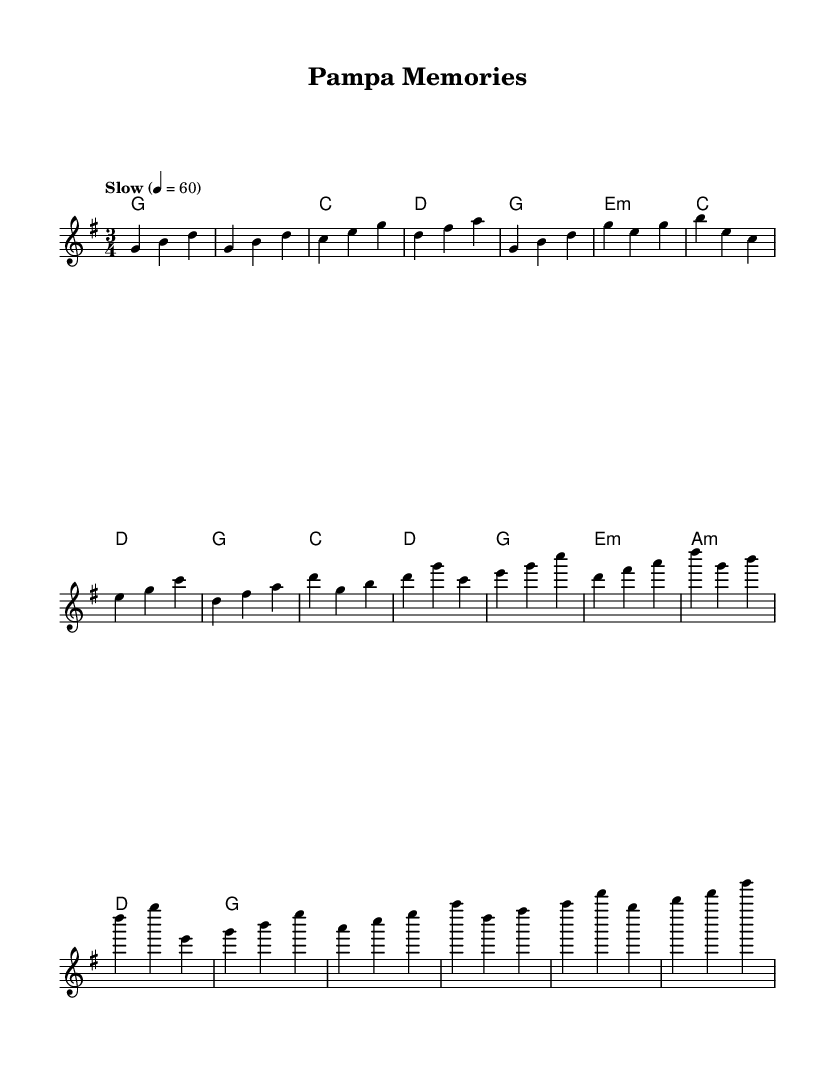What is the key signature of this music? The key signature is G major, which has one sharp (F#). This can be confirmed by examining the notes and identifying that the piece centers around G as the tonic.
Answer: G major What is the time signature of this music? The time signature is 3/4, indicated at the beginning of the score. This means there are three beats per measure, and each quarter note gets one beat.
Answer: 3/4 What is the tempo marking for this piece? The tempo marking is "Slow" set to 4 = 60, which means to play at 60 beats per minute. This is noted above the staff in the tempo indication.
Answer: Slow What chord follows the introduction? The chord following the introduction is E minor (e:m). This can be deduced by looking at the chord progression after the intro section in the harmony part.
Answer: E minor What is the structure of the song? The structure consists of an Intro, Verse 1, Chorus, and Bridge. This can be observed from the arrangement of the sections in the melody and harmony parts.
Answer: Intro, Verse 1, Chorus, Bridge What emotion does this traditional ballad evoke? The traditional country ballad evokes nostalgia for homeland and cultural roots, which is common in the genre, often reflected in the lyrics and melodies that reminisce about past experiences.
Answer: Nostalgia 